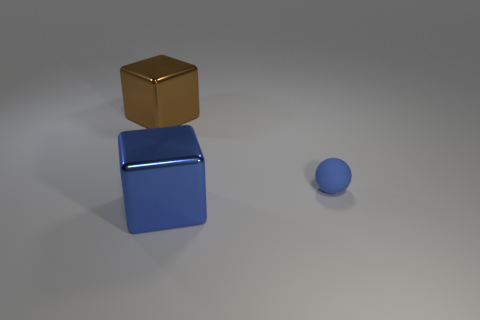What material is the object that is the same color as the matte ball?
Give a very brief answer. Metal. The shiny cube that is the same color as the small thing is what size?
Make the answer very short. Large. What material is the small blue ball?
Provide a short and direct response. Rubber. What number of other rubber things have the same size as the matte object?
Provide a short and direct response. 0. Are there an equal number of brown blocks in front of the large blue metallic block and blue metal objects that are right of the blue matte object?
Ensure brevity in your answer.  Yes. Is the material of the big brown thing the same as the blue block?
Provide a succinct answer. Yes. Is there a object that is behind the metal thing that is in front of the brown metal block?
Ensure brevity in your answer.  Yes. Is there a large blue shiny thing of the same shape as the small object?
Provide a short and direct response. No. There is a object left of the big metal thing that is in front of the sphere; what is its material?
Provide a short and direct response. Metal. How big is the blue block?
Offer a terse response. Large. 